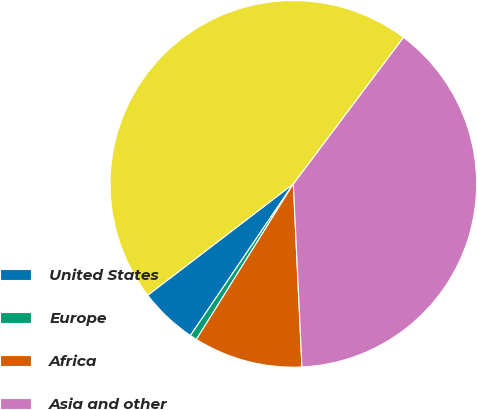Convert chart. <chart><loc_0><loc_0><loc_500><loc_500><pie_chart><fcel>United States<fcel>Europe<fcel>Africa<fcel>Asia and other<fcel>Total (b)<nl><fcel>5.12%<fcel>0.62%<fcel>9.62%<fcel>39.0%<fcel>45.64%<nl></chart> 